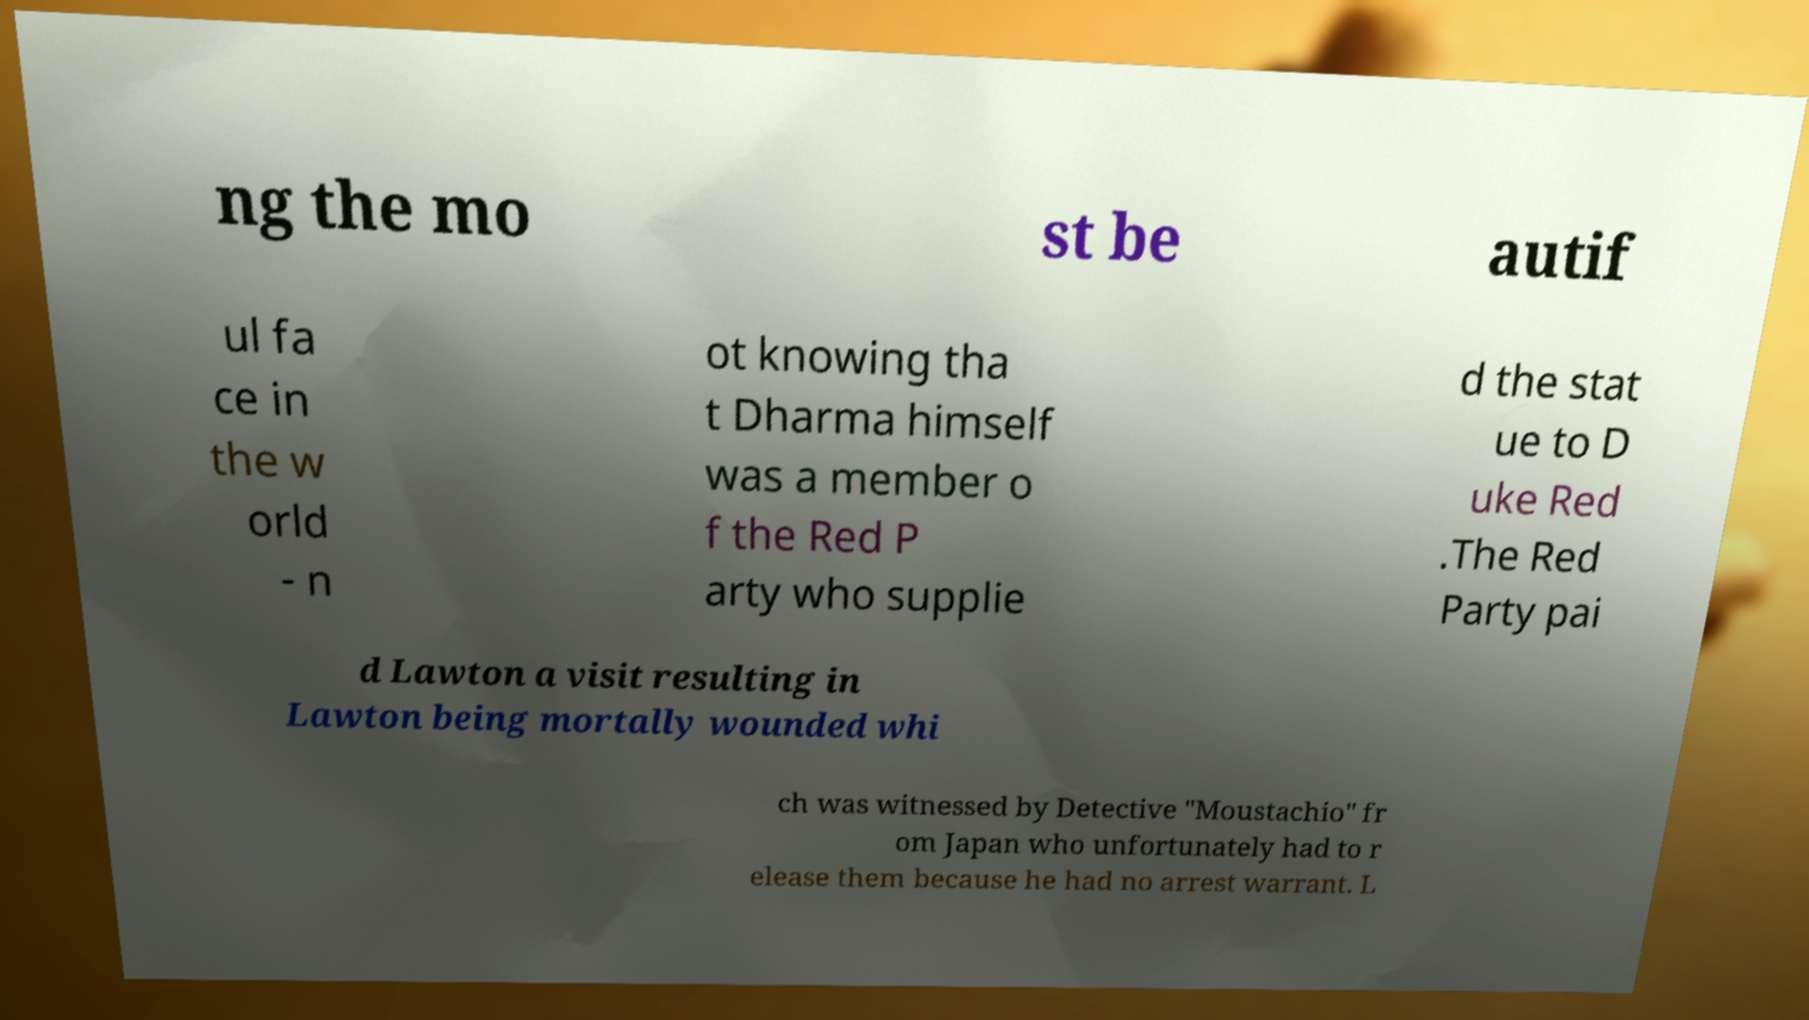Please identify and transcribe the text found in this image. ng the mo st be autif ul fa ce in the w orld - n ot knowing tha t Dharma himself was a member o f the Red P arty who supplie d the stat ue to D uke Red .The Red Party pai d Lawton a visit resulting in Lawton being mortally wounded whi ch was witnessed by Detective "Moustachio" fr om Japan who unfortunately had to r elease them because he had no arrest warrant. L 